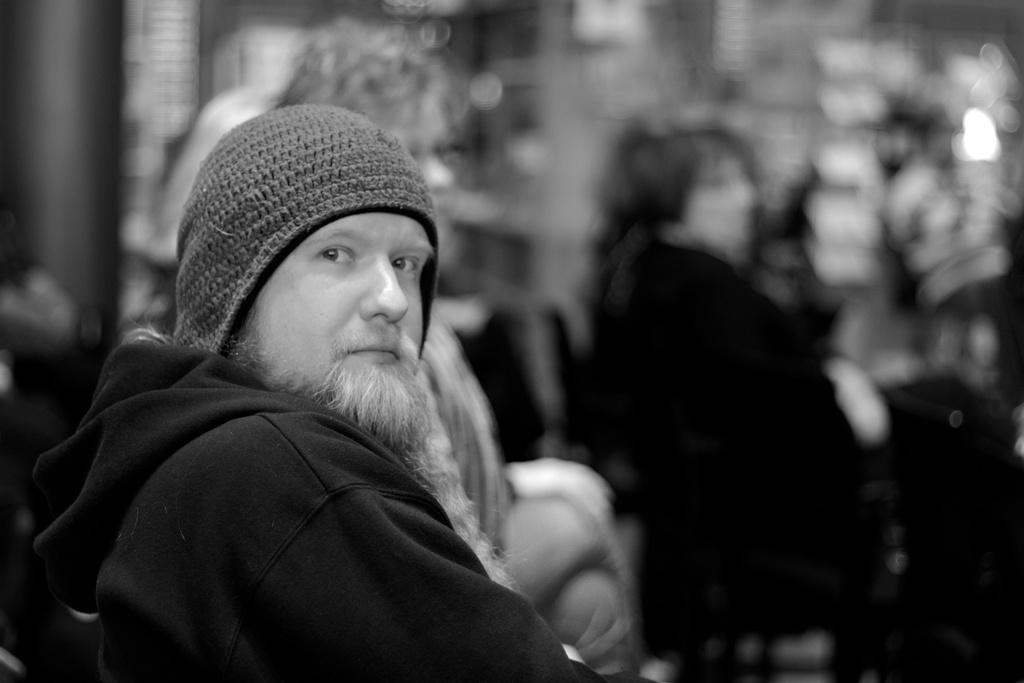What is the color scheme of the image? The image is black and white. What is the person in the image wearing on their head? The person in the image is wearing a cap. What type of clothing is the person wearing on their upper body? The person in the image is wearing a jerkin. How many people are present in the image? There are two people standing in the image. Can you describe the background of the image? The background of the image appears blurry. How many ladybugs can be seen crawling on the wire in the image? There are no ladybugs or wires present in the image. 